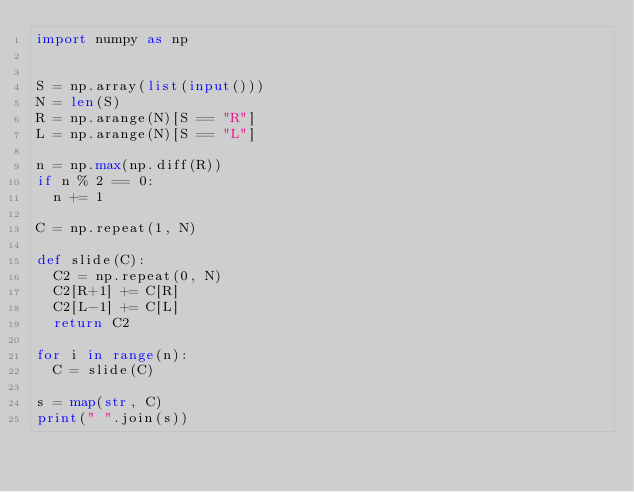<code> <loc_0><loc_0><loc_500><loc_500><_Python_>import numpy as np


S = np.array(list(input()))
N = len(S)
R = np.arange(N)[S == "R"]
L = np.arange(N)[S == "L"]
 
n = np.max(np.diff(R))
if n % 2 == 0:
  n += 1
 
C = np.repeat(1, N)
 
def slide(C):
  C2 = np.repeat(0, N)
  C2[R+1] += C[R]
  C2[L-1] += C[L]
  return C2
 
for i in range(n):
	C = slide(C)
 
s = map(str, C)
print(" ".join(s))
</code> 